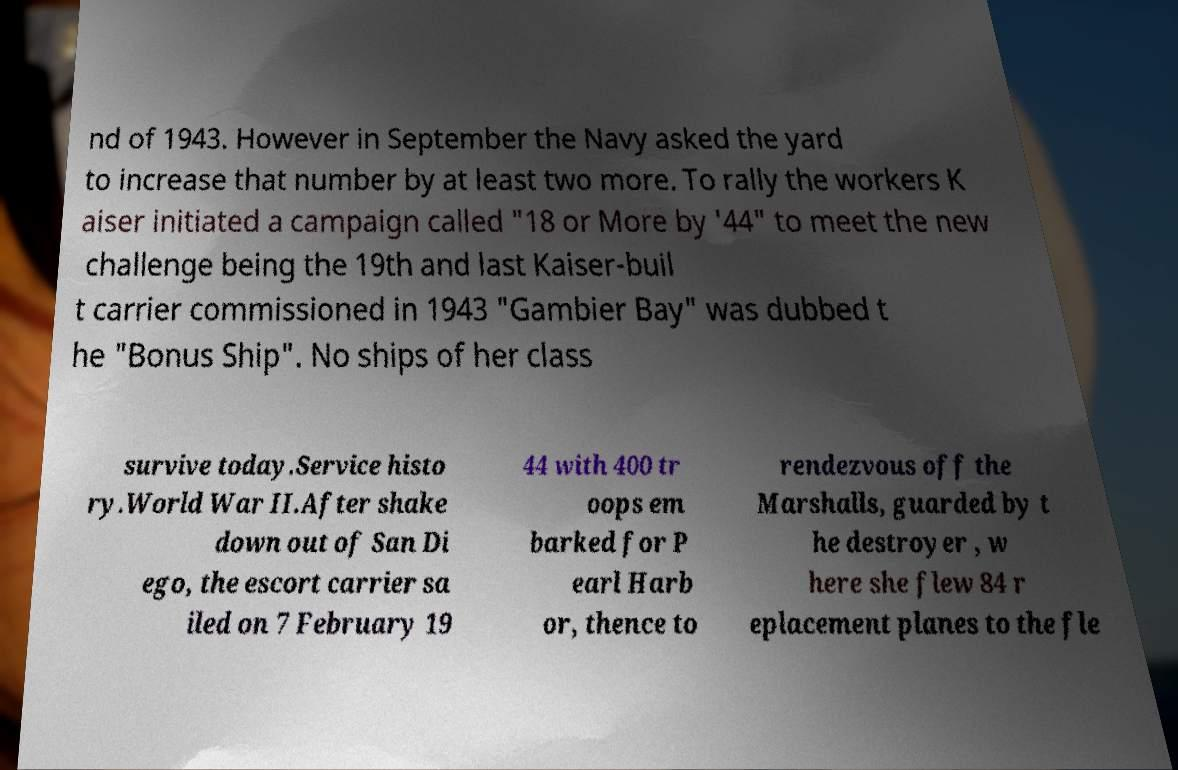What messages or text are displayed in this image? I need them in a readable, typed format. nd of 1943. However in September the Navy asked the yard to increase that number by at least two more. To rally the workers K aiser initiated a campaign called "18 or More by '44" to meet the new challenge being the 19th and last Kaiser-buil t carrier commissioned in 1943 "Gambier Bay" was dubbed t he "Bonus Ship". No ships of her class survive today.Service histo ry.World War II.After shake down out of San Di ego, the escort carrier sa iled on 7 February 19 44 with 400 tr oops em barked for P earl Harb or, thence to rendezvous off the Marshalls, guarded by t he destroyer , w here she flew 84 r eplacement planes to the fle 